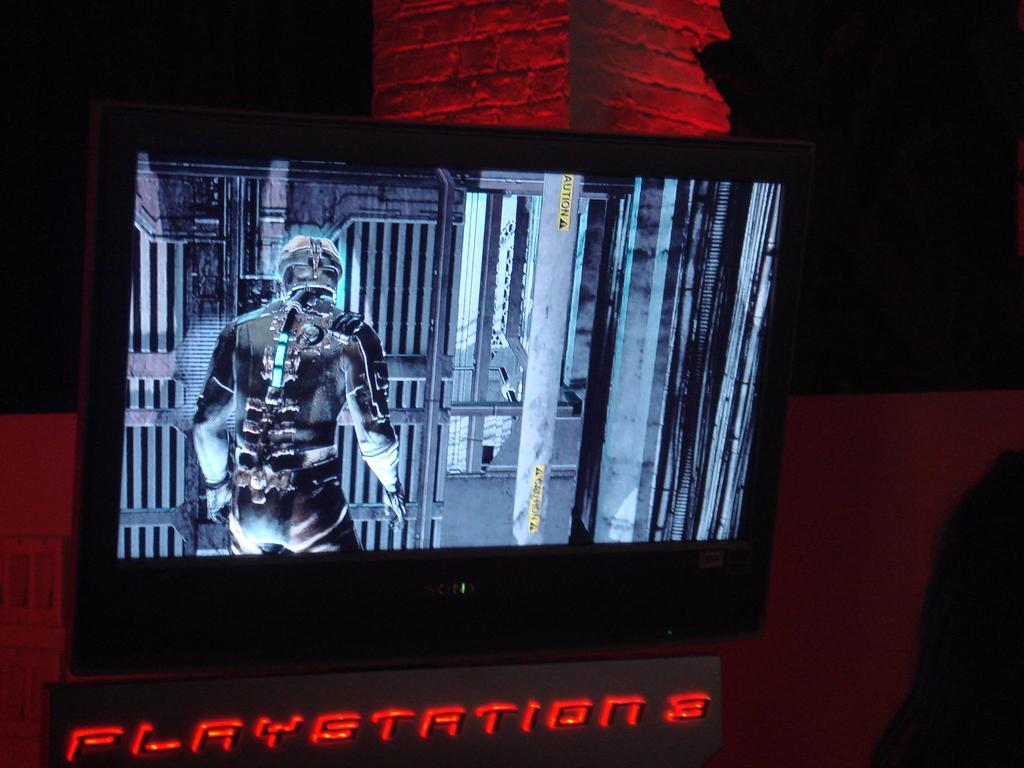<image>
Offer a succinct explanation of the picture presented. A Playstation 3 is set up below a television screen that is displaying a game on it. 